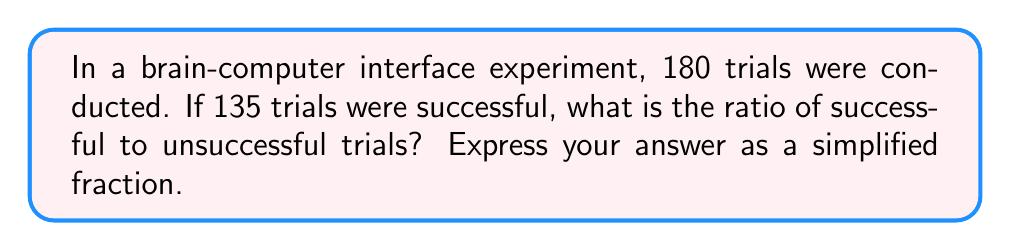Provide a solution to this math problem. To solve this problem, we'll follow these steps:

1. Identify the number of successful trials:
   Successful trials = 135

2. Calculate the number of unsuccessful trials:
   Total trials = 180
   Unsuccessful trials = Total trials - Successful trials
   Unsuccessful trials = 180 - 135 = 45

3. Set up the ratio of successful to unsuccessful trials:
   Ratio = Successful trials : Unsuccessful trials
   Ratio = 135 : 45

4. Simplify the ratio by dividing both numbers by their greatest common divisor (GCD):
   GCD of 135 and 45 is 45
   
   Simplified ratio = $(135 \div 45) : (45 \div 45)$
   Simplified ratio = $3 : 1$

Therefore, the simplified ratio of successful to unsuccessful trials is 3:1.
Answer: $3:1$ 